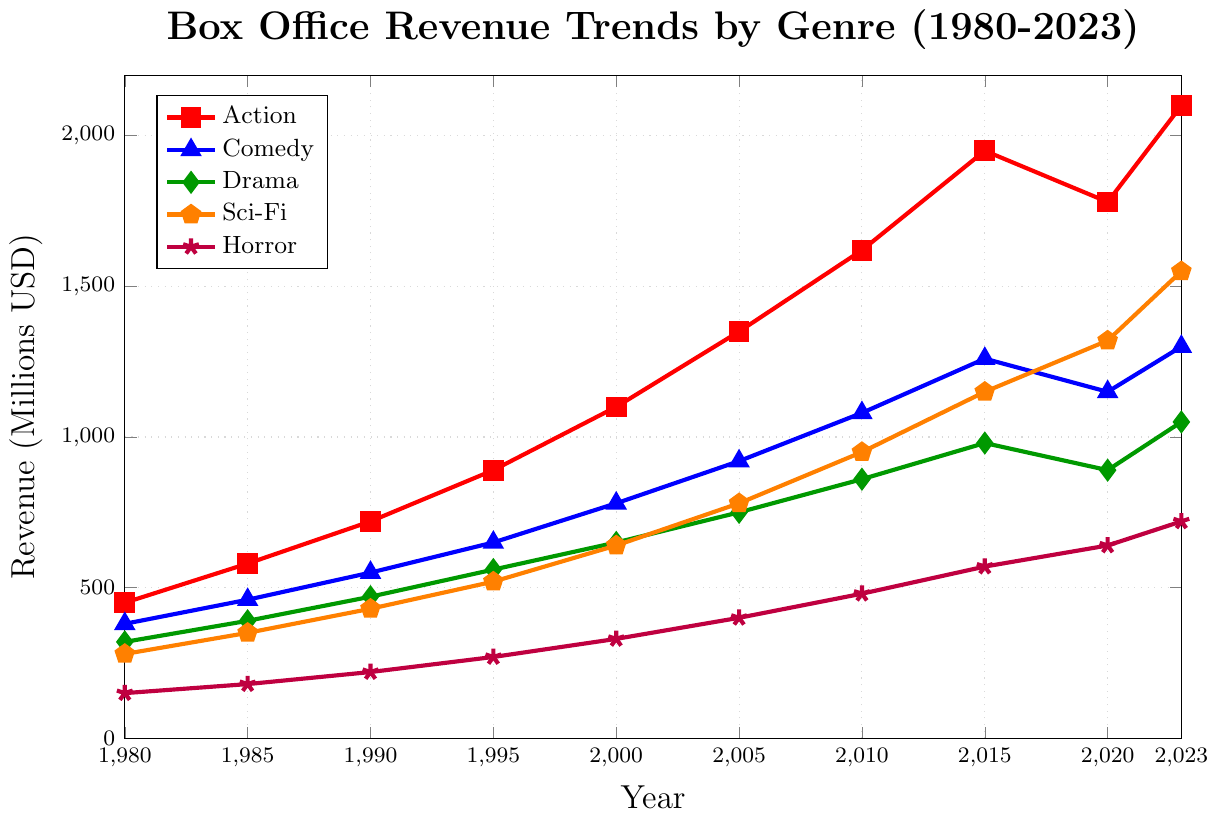Which genre saw the highest box office revenue in 2023? The plot shows lines of different genres with their respective revenues. The red line representing Action peaks at 2100 million USD, which is the highest among all genres in 2023.
Answer: Action How much did the box office revenue for Horror increase from 1980 to 2023? The revenue for Horror in 1980 was 150 million USD, and in 2023 it was 720 million USD. The increase is 720 - 150 = 570 million USD.
Answer: 570 million USD Compare the trends of Action and Comedy genres from 1980 to 2023. Which one had more growth? In 1980, the revenue for Action was 450 million USD and Comedy was 380 million USD. In 2023, the revenue for Action was 2100 million USD and Comedy was 1300 million USD. So, Action's growth is 2100 - 450 = 1650 million USD, while Comedy's growth is 1300 - 380 = 920 million USD. Action had more growth.
Answer: Action Determine the percentage increase in revenue for Sci-Fi from 1980 to 2023. In 1980, Sci-Fi revenue was 280 million USD, and in 2023, it was 1550 million USD. The increase is 1550 - 280 = 1270 million USD. The percentage increase is (1270 / 280) * 100 ≈ 453.57%.
Answer: 453.57% In which year did the revenue for Comedy surpass 500 million USD? Checking the plot, it appears that Comedy revenue was first greater than 500 million USD in 1990, reaching 550 million USD.
Answer: 1990 Which genre's revenue growth slowed down between 2015 and 2020? By observing the slopes of the lines from 2015 to 2020, it appears that Action's revenue decreased from 1950 million USD in 2015 to 1780 million USD in 2020, indicating a slowed growth.
Answer: Action What was the difference in box office revenue between Drama and Sci-Fi in 2010? In 2010, Drama's revenue was 860 million USD, and Sci-Fi's revenue was 950 million USD. The difference is 950 - 860 = 90 million USD.
Answer: 90 million USD Which two genres had approximately equal revenues in 2000? By examining the plot, Comedy had around 780 million USD, and Sci-Fi had around 640 million USD in 2000. These two are not equal but close in values.
Answer: Comedy and Sci-Fi Compare the growth rates of Drama and Horror between 2000 and 2023. Drama's revenue in 2000 was 650 million USD and in 2023 it was 1050 million USD. Growth is 1050 - 650 = 400 million USD. Horror's revenue in 2000 was 330 million USD and in 2023 it was 720 million USD. Growth is 720 - 330 = 390 million USD.
Answer: Drama had a higher growth rate by 10 million USD Identify any genres with declining revenue between two consecutive periods. By examining the plot, from 2015 to 2020, Action saw a decline from 1950 million USD to 1780 million USD.
Answer: Action 